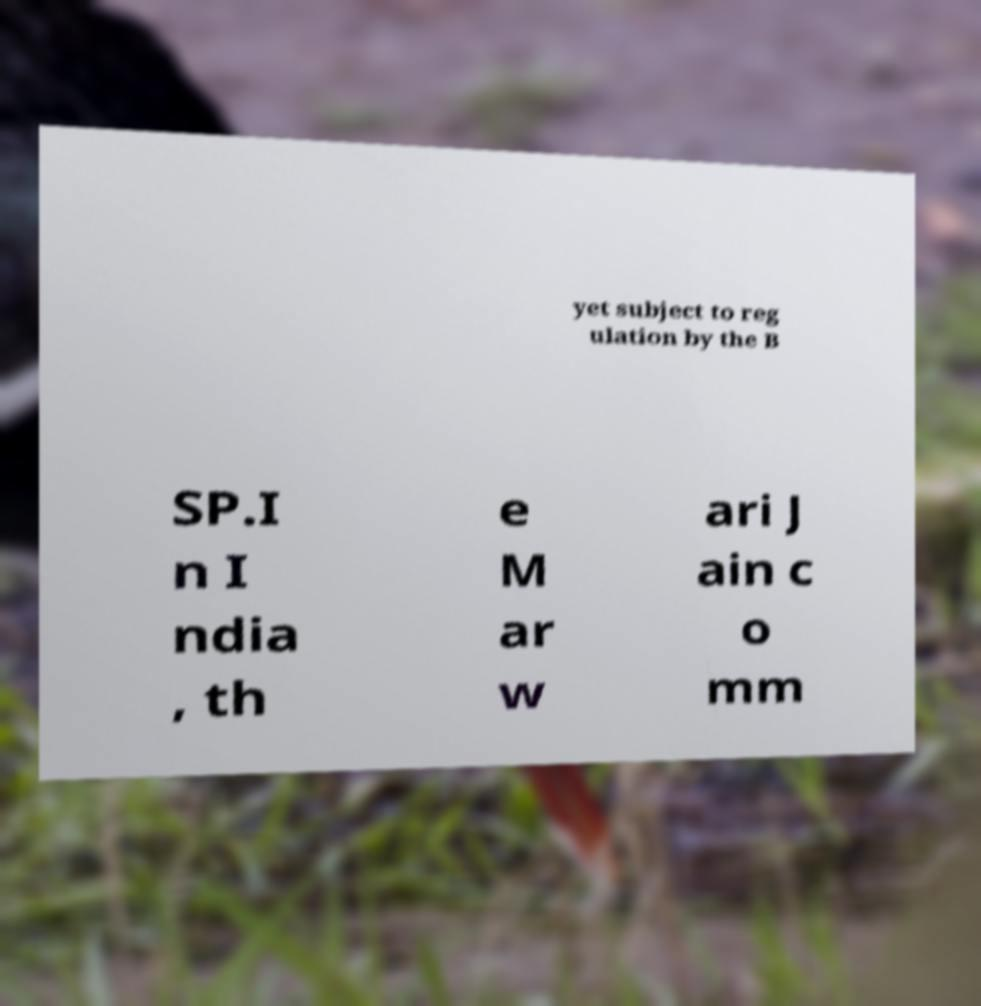Can you read and provide the text displayed in the image?This photo seems to have some interesting text. Can you extract and type it out for me? yet subject to reg ulation by the B SP.I n I ndia , th e M ar w ari J ain c o mm 